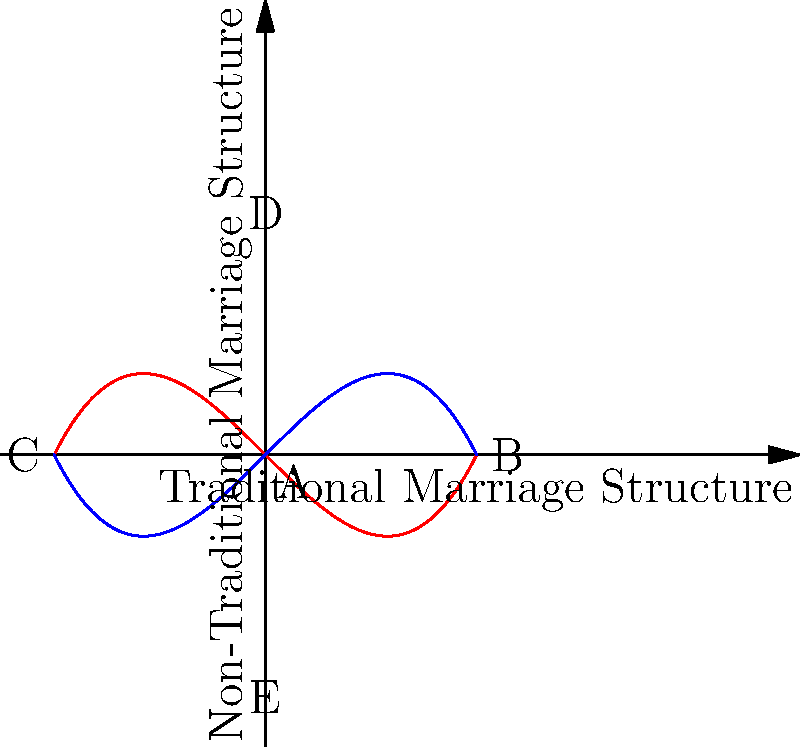Consider the topological space represented by the graph, where the red curve represents traditional marriage structures and the blue curve represents non-traditional marriage structures. Which of the following statements about the homeomorphic properties of these structures is correct? To answer this question, we need to analyze the topological properties of the curves representing traditional and non-traditional marriage structures:

1. Both curves are continuous and have no breaks, representing the continuity of social structures in both traditional and non-traditional marriages.

2. The curves intersect at point A (0,0), suggesting a common ground or shared characteristics between traditional and non-traditional marriages.

3. The red curve (traditional marriage) extends from point C to point B along the x-axis, while the blue curve (non-traditional marriage) extends from point E to point D along the y-axis.

4. The curves are mirror images of each other, rotated 90 degrees, indicating a topological equivalence or homeomorphism between traditional and non-traditional marriage structures.

5. Both curves are bijective (one-to-one and onto) mappings between their respective domains and ranges, preserving the topological properties of continuity and invertibility.

6. The curves can be continuously deformed into each other without cutting or gluing, which is a key property of homeomorphic spaces.

Given these observations, we can conclude that the traditional and non-traditional marriage structures, as represented by these curves, are indeed homeomorphic. This implies that despite their apparent differences, they share fundamental topological properties and can be transformed into one another while preserving their essential structural characteristics.
Answer: The traditional and non-traditional marriage structures are homeomorphic. 